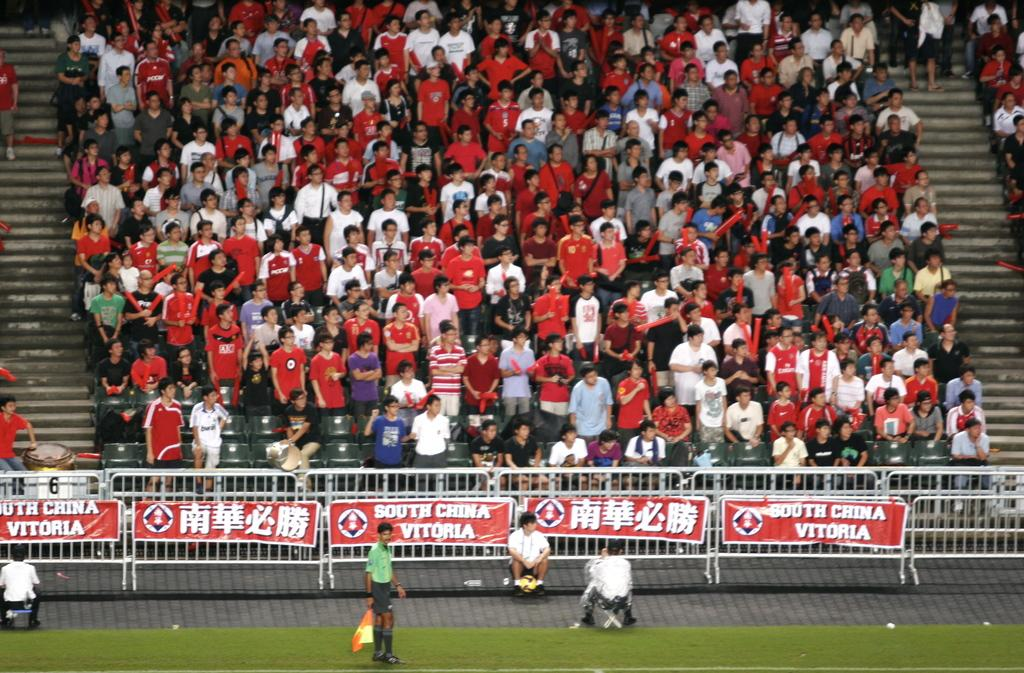<image>
Describe the image concisely. A stadium full of people watcha sports game with signs that say South China Vitoria. 